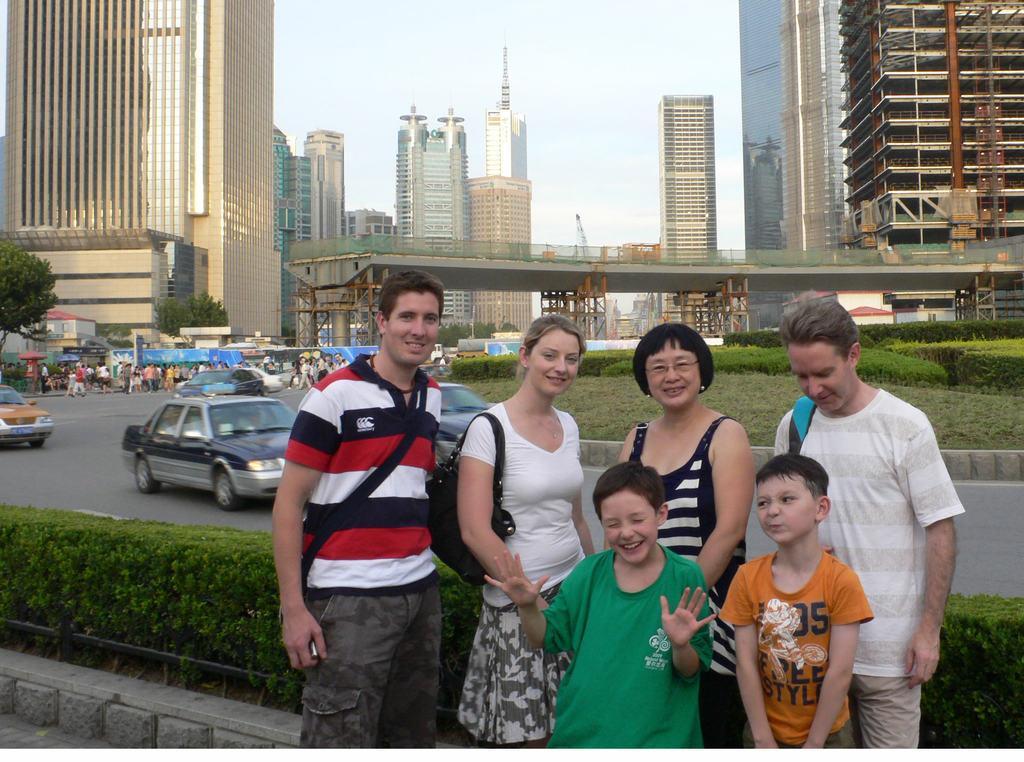Could you give a brief overview of what you see in this image? In the center of the image we can see people standing and there are cars on the road. In the background there are buildings, trees, hedges, people, bridge and sky. 